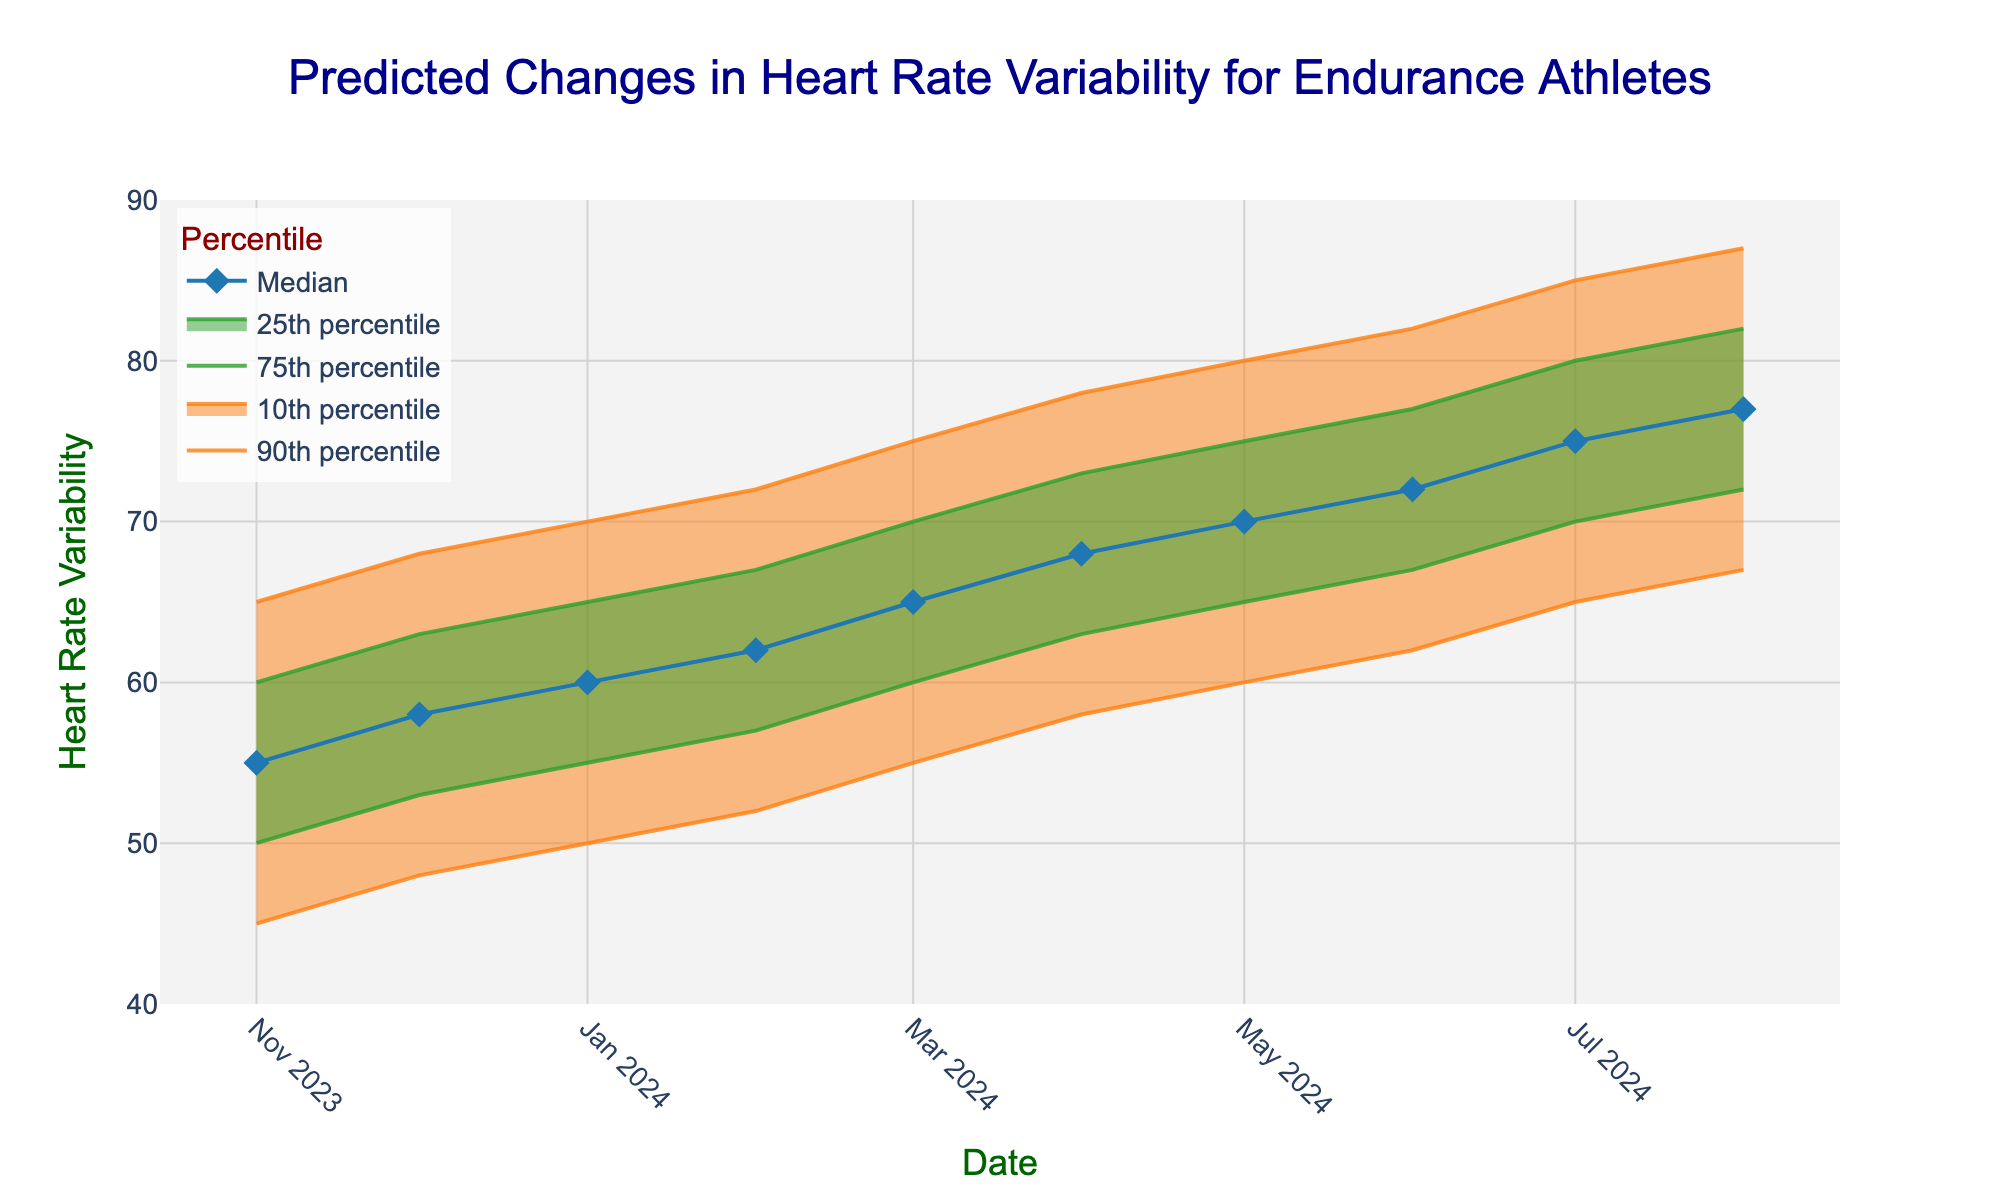What is the title of the plot? The title is usually located at the top of the plot and is generally larger and bolder than other text elements. Look at the central top part for this information.
Answer: Predicted Changes in Heart Rate Variability for Endurance Athletes What date is on the x-axis at the beginning of the training season? The x-axis represents the time series, and the beginning of the training season is typically the first data point on the graph. Check the leftmost part of the x-axis.
Answer: 2023-11-01 What is the median heart rate variability for May 1, 2024? Locate the 'Median' trace in the legend, identify its corresponding marker style, and track it to May 1, 2024 on the x-axis. Then find the y-axis value for that date.
Answer: 70 What are the upper and lower 90th percentiles for August 1, 2024? For 90th percentile ranges, identify the '90th percentile' traces in the legend, then find their y-values at August 1, 2024 on the x-axis.
Answer: 87 and 67 Which date shows the largest median heart rate variability? Track the 'Median' line and pinpoint which date it reaches the highest y-axis value.
Answer: August 1, 2024 During which month does the upper 75th percentile reach 75 on the y-axis? Locate the '75th percentile' trace, follow it to where it hits the value of 75 on the y-axis, then find the corresponding x-axis date.
Answer: May 2024 How much is the increase in the median heart rate variability from January 1, 2024, to July 1, 2024? Find the median values for January 1, 2024, and July 1, 2024, and calculate the difference between them. Median value for January 1 is 60, and for July 1 is 75, so the increase is 75 - 60.
Answer: 15 By how much did the upper 90th percentile change from November 1, 2023, to February 1, 2024? Locate the upper 90th percentile for both dates and subtract the November 1 value from the February 1 value. 72 - 65 = 7
Answer: 7 At which date do the lower 10th and lower 25th percentiles first exceed 65 and 70, respectively? Track the '10th percentile' and '25th percentile' lines and check when each crosses y-axis values of 65 and 70.
Answer: November 1, 2023, for the 10th percentile and January 1, 2024, for the 25th percentile Does the fan chart indicate a general increase or decrease in heart rate variability over time? Observe the trends in the percentiles and median lines; a generally upward slope indicates an increase, whereas downward indicates a decrease.
Answer: Increase 